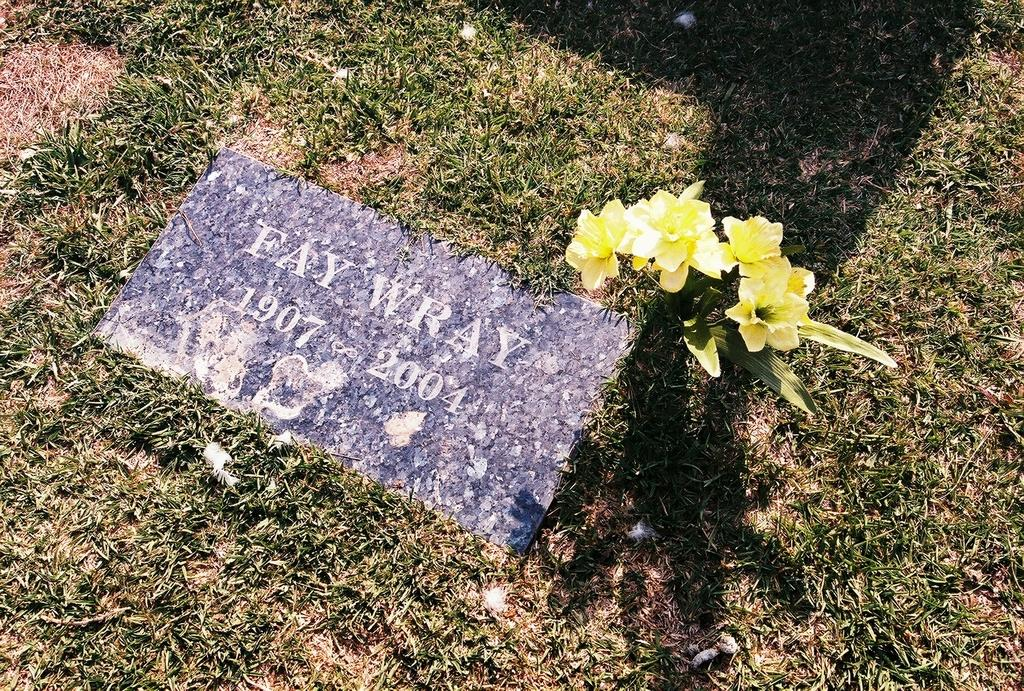What is the main subject in the center of the image? There is a tile in the center of the image. What can be seen on the tile? There is text and flowers on the tile. What type of vegetation is visible in the background of the image? There is grass in the background of the image. What else can be seen in the background of the image? There is some scrap visible in the background. How does the cream balance on the tile in the image? There is no cream present in the image, so it cannot be balanced on the tile. 